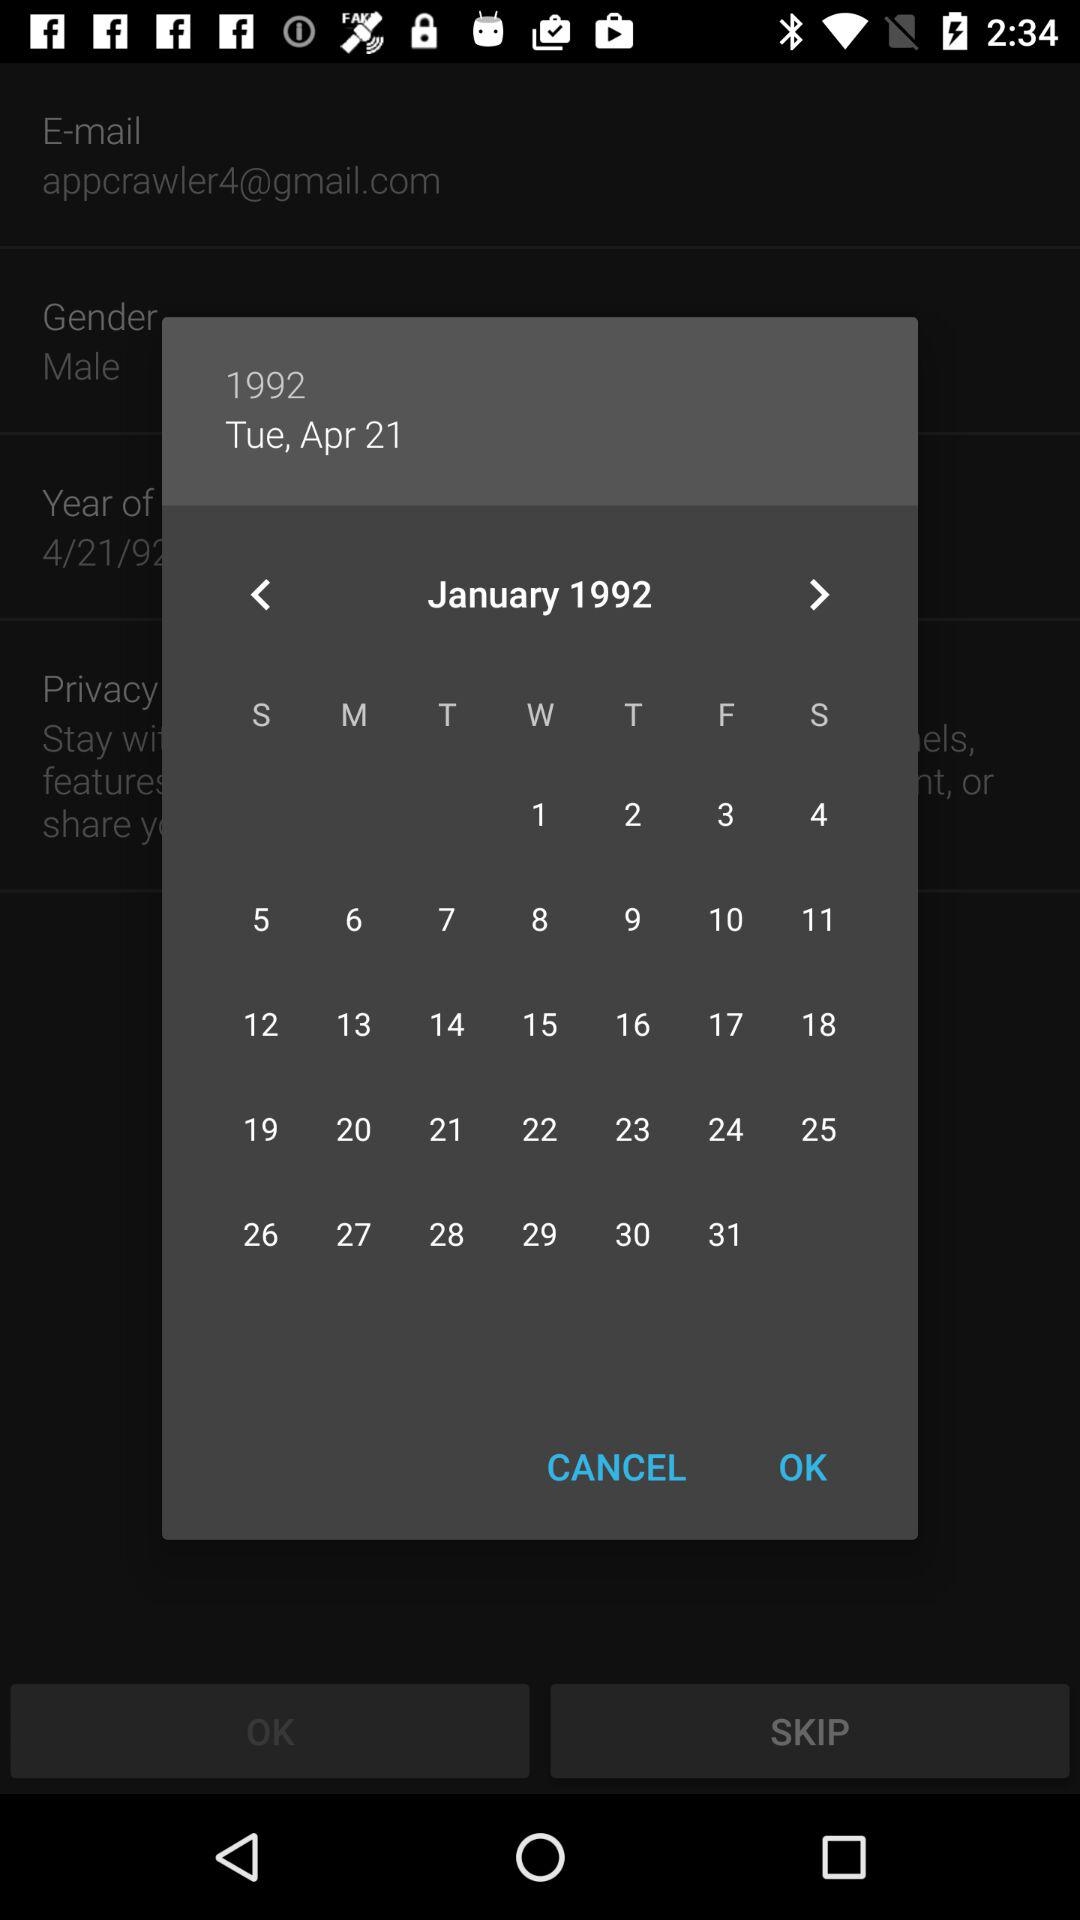What day is shown? The day is Tuesday. 